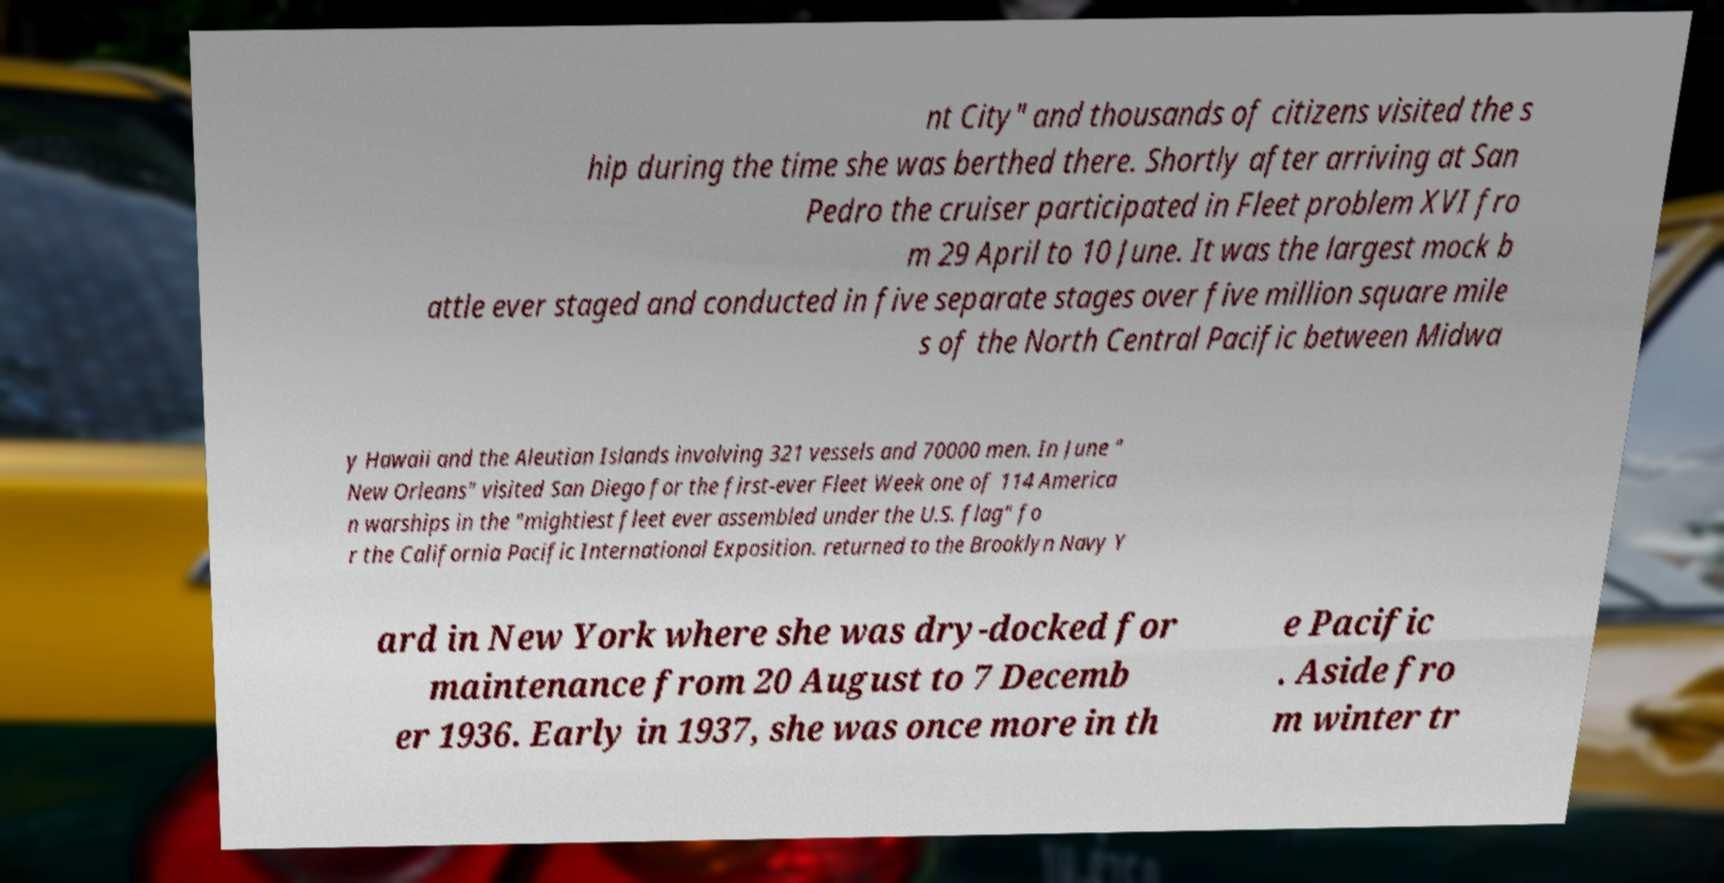What messages or text are displayed in this image? I need them in a readable, typed format. nt City" and thousands of citizens visited the s hip during the time she was berthed there. Shortly after arriving at San Pedro the cruiser participated in Fleet problem XVI fro m 29 April to 10 June. It was the largest mock b attle ever staged and conducted in five separate stages over five million square mile s of the North Central Pacific between Midwa y Hawaii and the Aleutian Islands involving 321 vessels and 70000 men. In June " New Orleans" visited San Diego for the first-ever Fleet Week one of 114 America n warships in the "mightiest fleet ever assembled under the U.S. flag" fo r the California Pacific International Exposition. returned to the Brooklyn Navy Y ard in New York where she was dry-docked for maintenance from 20 August to 7 Decemb er 1936. Early in 1937, she was once more in th e Pacific . Aside fro m winter tr 